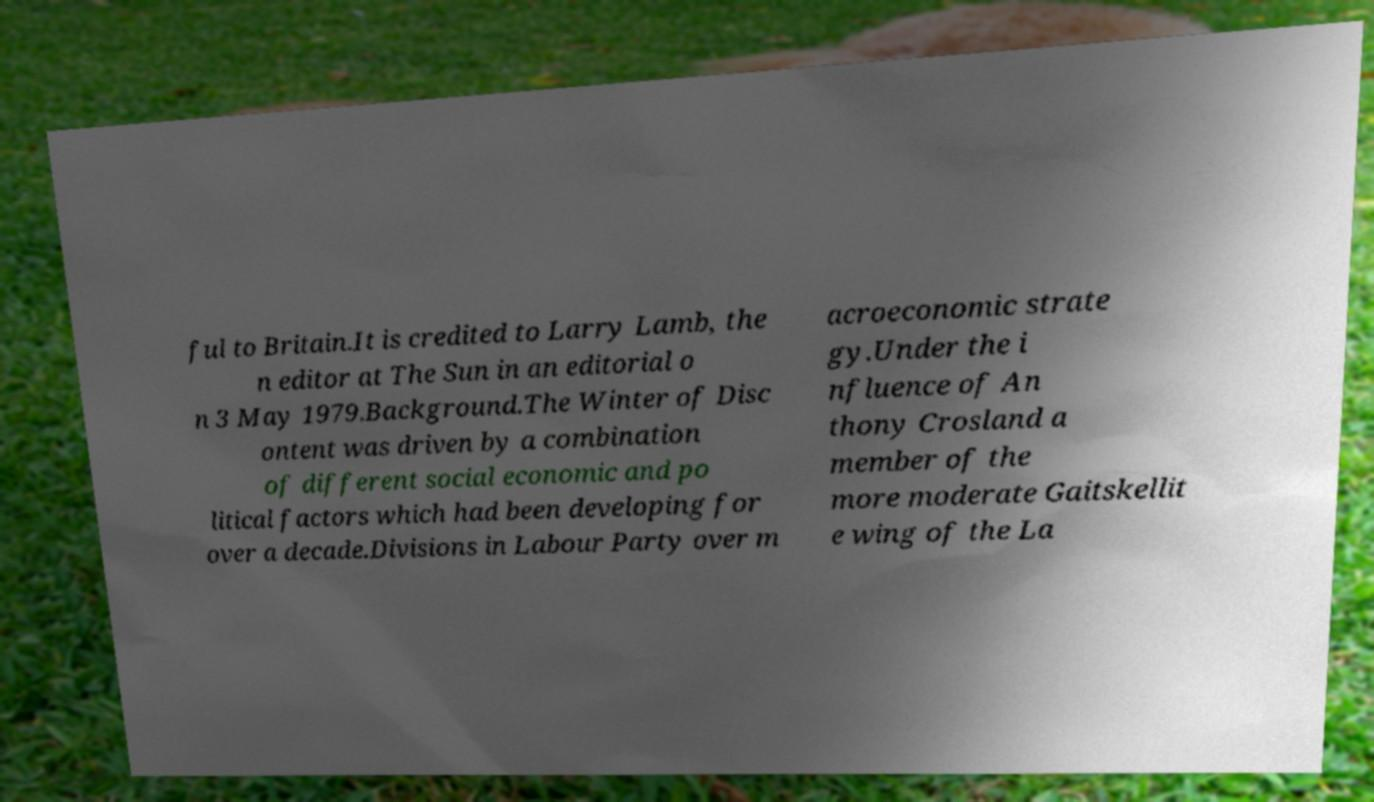Could you extract and type out the text from this image? ful to Britain.It is credited to Larry Lamb, the n editor at The Sun in an editorial o n 3 May 1979.Background.The Winter of Disc ontent was driven by a combination of different social economic and po litical factors which had been developing for over a decade.Divisions in Labour Party over m acroeconomic strate gy.Under the i nfluence of An thony Crosland a member of the more moderate Gaitskellit e wing of the La 